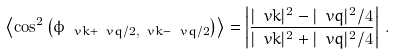<formula> <loc_0><loc_0><loc_500><loc_500>\left \langle \cos ^ { 2 } \left ( \phi _ { \ v k + \ v q / 2 , \ v k - \ v q / 2 } \right ) \right \rangle = \left | \frac { | \ v k | ^ { 2 } - | \ v q | ^ { 2 } / 4 } { | \ v k | ^ { 2 } + | \ v q | ^ { 2 } / 4 } \right | \, .</formula> 